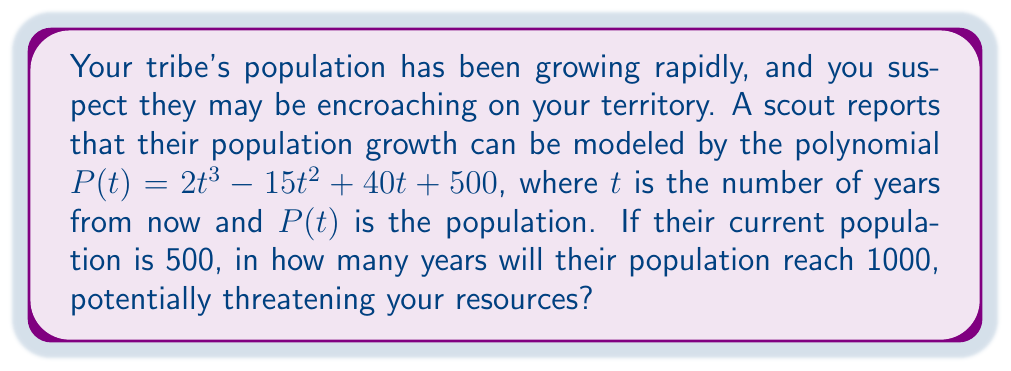Can you solve this math problem? To solve this problem, we need to find the value of $t$ when $P(t) = 1000$. Let's approach this step-by-step:

1) Set up the equation:
   $1000 = 2t^3 - 15t^2 + 40t + 500$

2) Simplify by subtracting 500 from both sides:
   $500 = 2t^3 - 15t^2 + 40t$

3) Rearrange the equation to standard form:
   $2t^3 - 15t^2 + 40t - 500 = 0$

4) This is a cubic equation. While it can be solved algebraically, it's complex. Instead, we can use numerical methods or graphing to find the solution.

5) Using a graphing calculator or computer algebra system, we can find that this equation has one real root at approximately $t ≈ 5.95$.

6) Since we're dealing with years, we need to round up to the nearest whole number.

Therefore, the population will reach 1000 in 6 years.
Answer: 6 years 